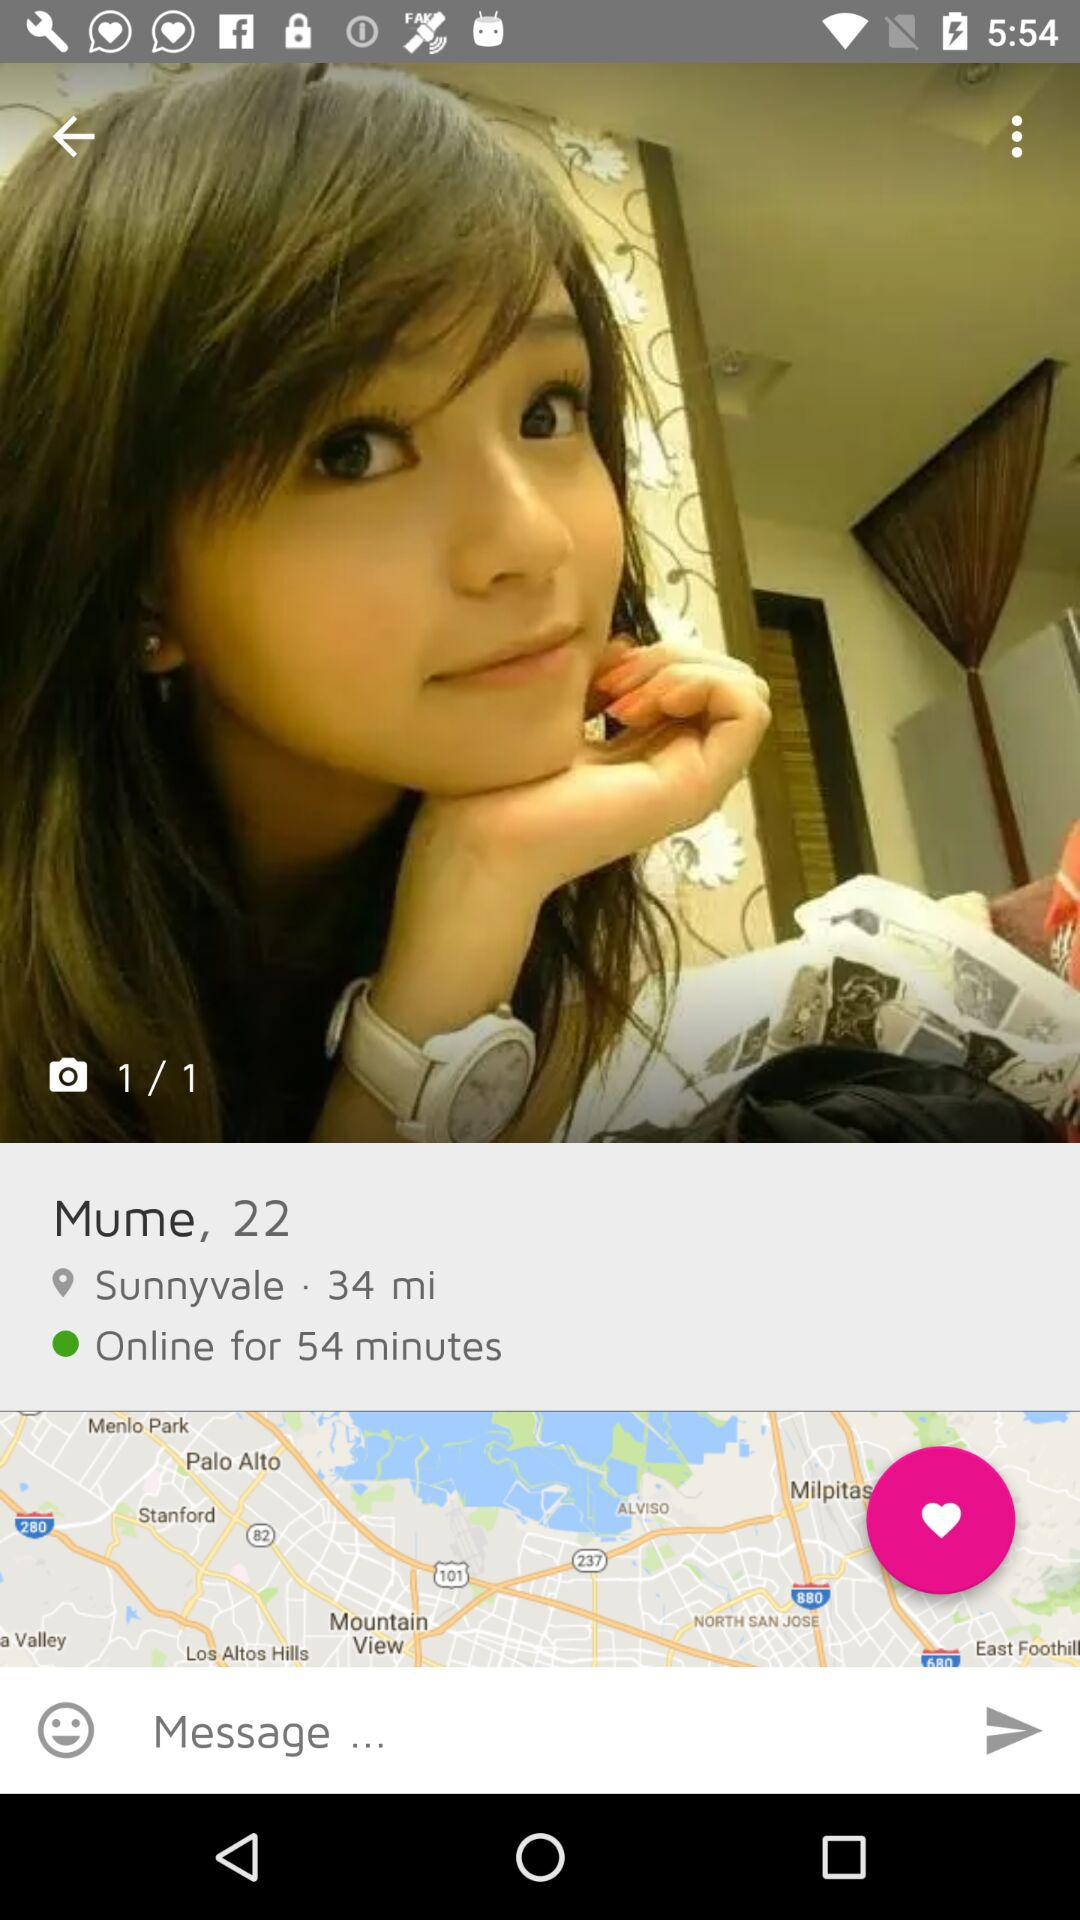How many images in total are there? There is 1 image. 